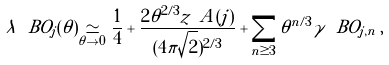<formula> <loc_0><loc_0><loc_500><loc_500>\lambda ^ { \ } B O _ { j } ( \theta ) \underset { \theta \to 0 } { \simeq } \frac { 1 } { 4 } + \frac { 2 \theta ^ { 2 / 3 } z _ { \ } A ( j ) } { ( 4 \pi \sqrt { 2 } ) ^ { 2 / 3 } } + \sum _ { n \geq 3 } \theta ^ { n / 3 } \gamma ^ { \ } B O _ { j , n } \, ,</formula> 